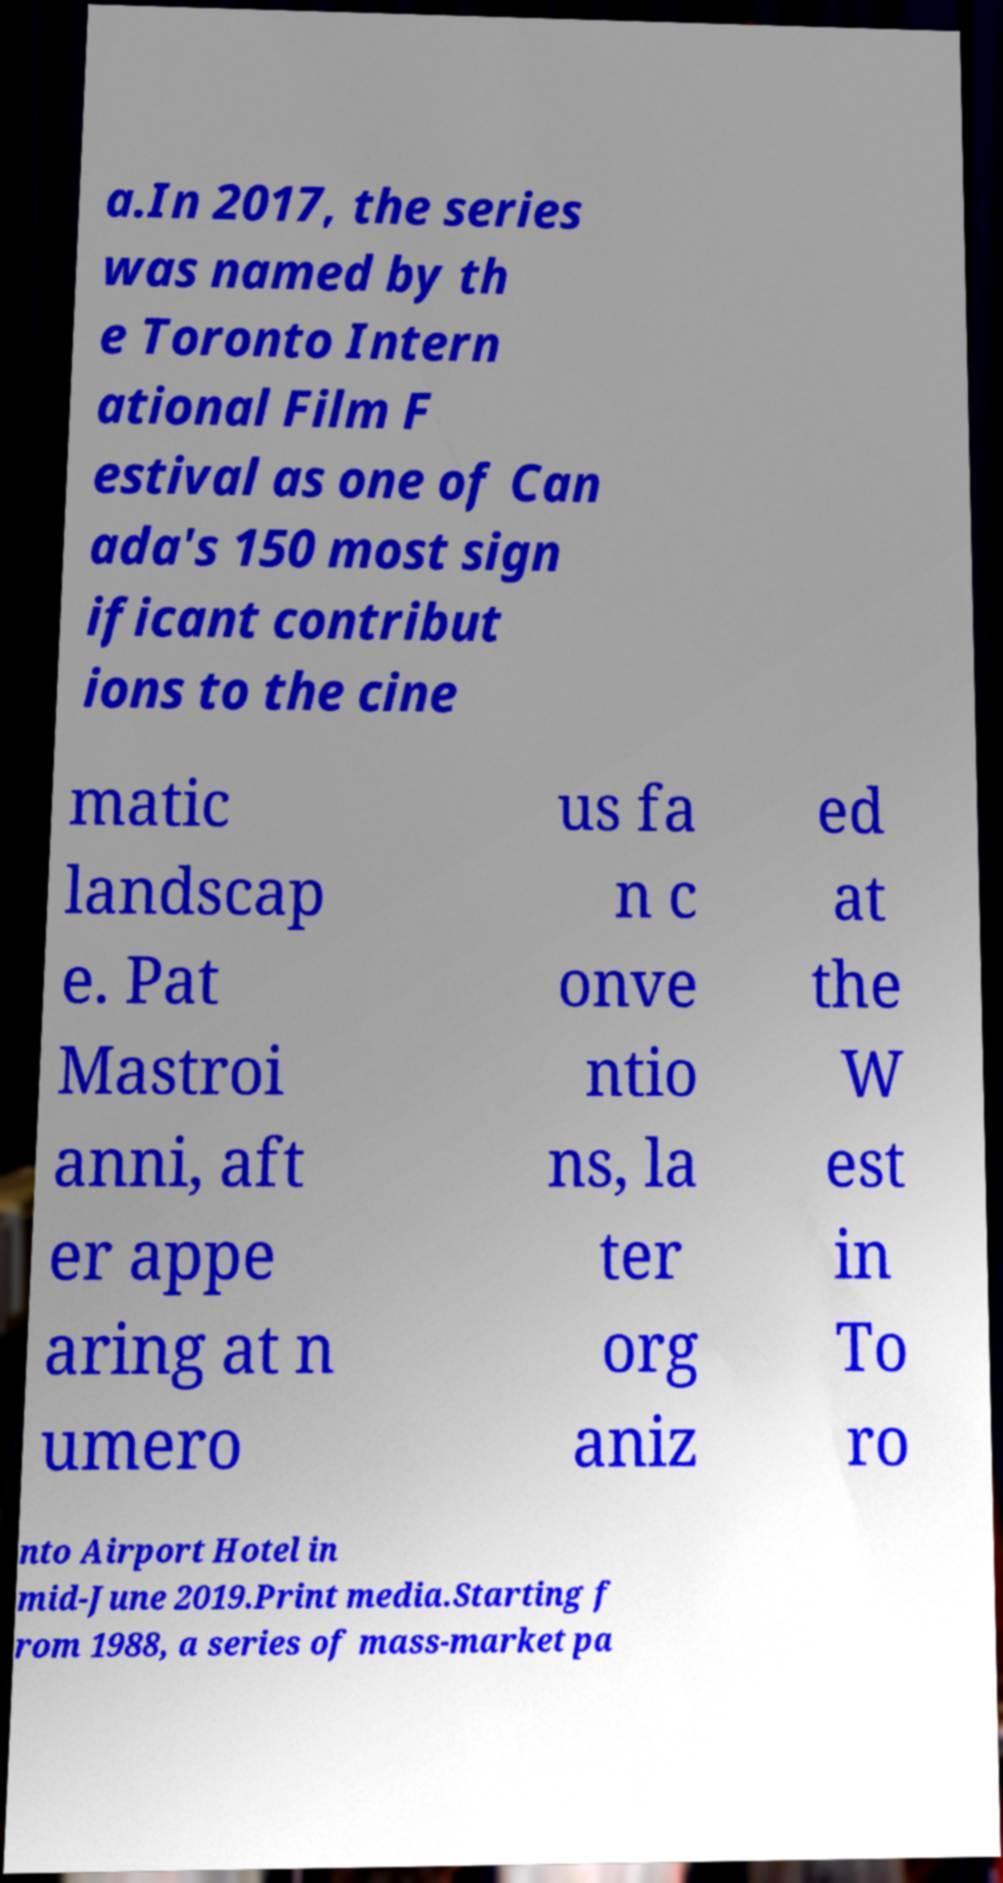Could you assist in decoding the text presented in this image and type it out clearly? a.In 2017, the series was named by th e Toronto Intern ational Film F estival as one of Can ada's 150 most sign ificant contribut ions to the cine matic landscap e. Pat Mastroi anni, aft er appe aring at n umero us fa n c onve ntio ns, la ter org aniz ed at the W est in To ro nto Airport Hotel in mid-June 2019.Print media.Starting f rom 1988, a series of mass-market pa 